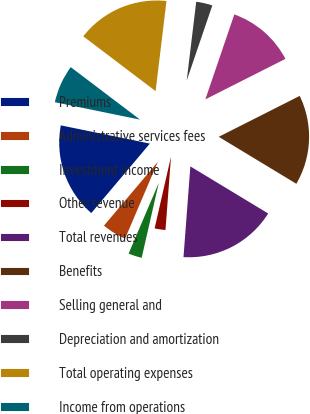<chart> <loc_0><loc_0><loc_500><loc_500><pie_chart><fcel>Premiums<fcel>Administrative services fees<fcel>Investment income<fcel>Other revenue<fcel>Total revenues<fcel>Benefits<fcel>Selling general and<fcel>Depreciation and amortization<fcel>Total operating expenses<fcel>Income from operations<nl><fcel>17.06%<fcel>4.74%<fcel>2.84%<fcel>2.37%<fcel>17.54%<fcel>16.11%<fcel>12.32%<fcel>3.32%<fcel>16.59%<fcel>7.11%<nl></chart> 